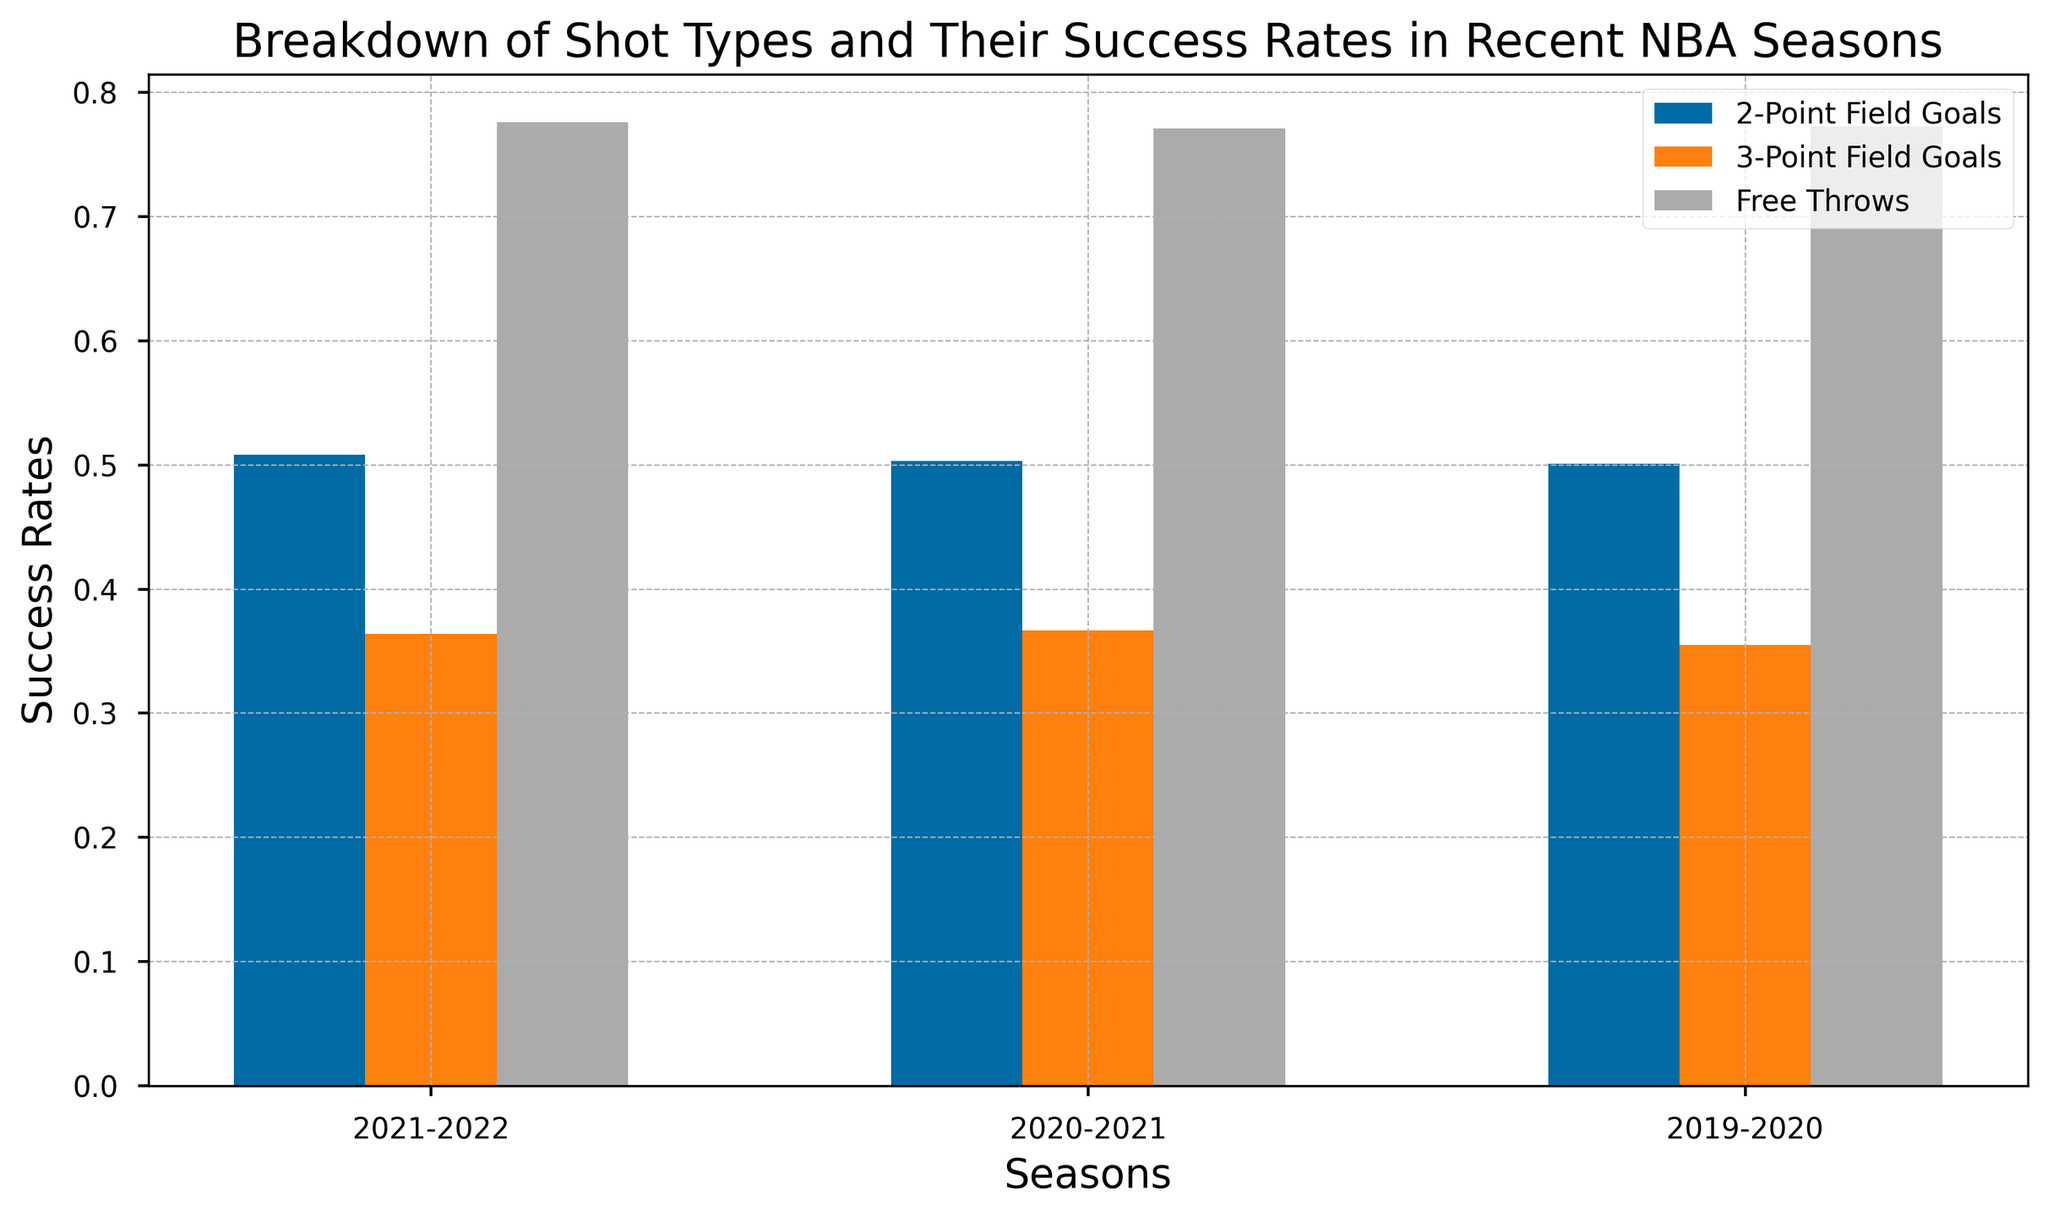Which shot type had the highest success rate in the 2021-2022 season? By looking at the bars labeled "2021-2022", identify which bar is the tallest. The "Free Throws" bar is the highest, representing the highest success rate.
Answer: Free Throws Which season had the lowest success rate for 3-Point Field Goals? Compare the heights of the bars labeled "3-Point Field Goals" across all seasons. The shortest bar is for the 2019-2020 season.
Answer: 2019-2020 How did the success rates for 2-Point Field Goals change from the 2019-2020 to the 2021-2022 season? Subtract the success rate of 2-Point Field Goals in 2019-2020 from that in 2021-2022. The difference is 0.508 - 0.501 = 0.007.
Answer: Increased by 0.007 Which season had the most consistent success rate across all shot types? Check which season has the smallest difference between the tallest and shortest bars. The 2020-2021 season has the success rates 0.503, 0.367, and 0.771, which are the closest in range.
Answer: 2020-2021 What is the average success rate for Free Throws across all seasons? Add the success rates for Free Throws across all seasons and divide by the number of seasons. The calculation is (0.776 + 0.771 + 0.773) / 3 = 0.7733.
Answer: 0.7733 Is there a season where the success rate for Free Throws was higher than any other shot type in that season? Compare the Free Throws success rates with the other shot types' success rates within each season. In 2021-2022, the Free Throws success rate (0.776) is higher than the 2-Point (0.508) and 3-Point (0.364) success rates.
Answer: Yes What was the trend in the success rate for 3-Point Field Goals from 2019-2020 to 2021-2022? Observe the heights of the bars for 3-Point Field Goals across the seasons. It increased from 0.355 in 2019-2020 to 0.364 in 2021-2022.
Answer: Increasing Which shot type had the smallest variability in success rates across the three seasons? Calculate the range (difference between max and min) for each shot type's success percentages and compare. The range for Free Throws is the smallest: 0.776 - 0.771 = 0.005.
Answer: Free Throws 